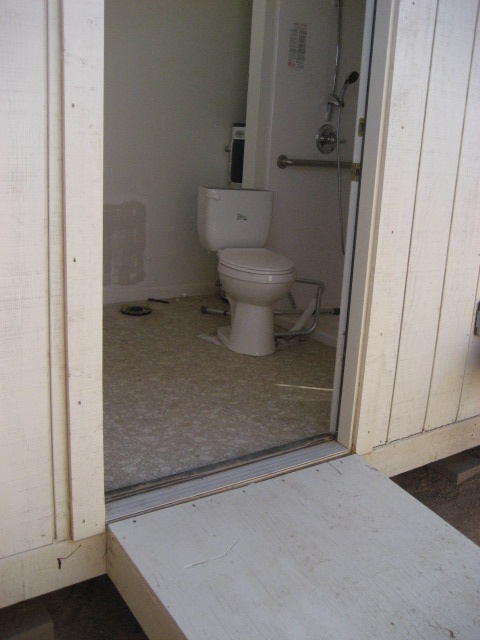Describe the objects in this image and their specific colors. I can see a toilet in darkgray, gray, and black tones in this image. 